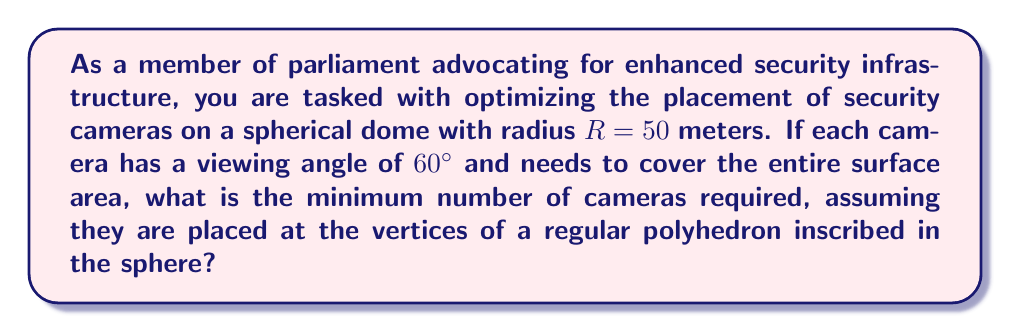Can you answer this question? To solve this problem, we'll follow these steps:

1) First, we need to determine which regular polyhedron will provide the most efficient coverage. The platonic solids that can be inscribed in a sphere are:
   - Tetrahedron (4 vertices)
   - Cube (8 vertices)
   - Octahedron (6 vertices)
   - Dodecahedron (20 vertices)
   - Icosahedron (12 vertices)

2) The icosahedron provides the most uniform coverage with the least number of vertices among these options.

3) Now, we need to calculate the surface area of the sphere:
   $$A = 4\pi R^2 = 4\pi (50)^2 = 31415.93 \text{ m}^2$$

4) Next, we calculate the area covered by each camera. The cameras are placed at the vertices of the icosahedron, so each camera needs to cover a spherical cap.

5) The area of a spherical cap is given by:
   $$A_{cap} = 2\pi R h$$
   where $h$ is the height of the cap.

6) For a $60°$ viewing angle, the height of the cap is:
   $$h = R(1 - \cos 30°) = 50(1 - \frac{\sqrt{3}}{2}) = 6.70 \text{ m}$$

7) Therefore, the area covered by each camera is:
   $$A_{cap} = 2\pi (50)(6.70) = 2103.45 \text{ m}^2$$

8) The number of cameras needed is:
   $$N = \frac{\text{Total Area}}{\text{Area per Camera}} = \frac{31415.93}{2103.45} = 14.93$$

9) Rounding up, we need at least 15 cameras.

10) However, since we're using an icosahedron which has 12 vertices, we need to use all 12 vertices to ensure complete coverage.

Therefore, the minimum number of cameras required is 12, placed at the vertices of an icosahedron inscribed in the spherical dome.
Answer: 12 cameras 